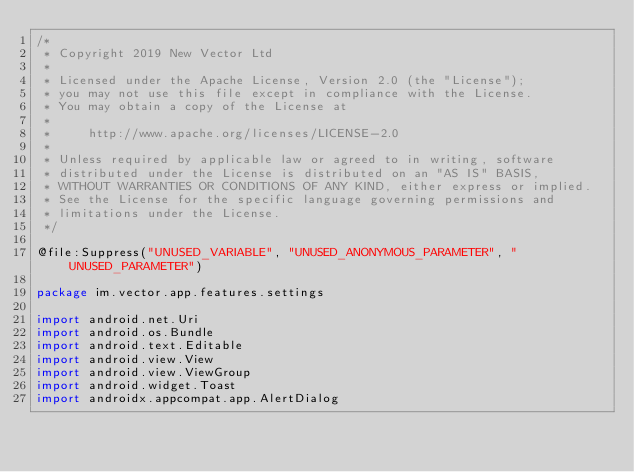<code> <loc_0><loc_0><loc_500><loc_500><_Kotlin_>/*
 * Copyright 2019 New Vector Ltd
 *
 * Licensed under the Apache License, Version 2.0 (the "License");
 * you may not use this file except in compliance with the License.
 * You may obtain a copy of the License at
 *
 *     http://www.apache.org/licenses/LICENSE-2.0
 *
 * Unless required by applicable law or agreed to in writing, software
 * distributed under the License is distributed on an "AS IS" BASIS,
 * WITHOUT WARRANTIES OR CONDITIONS OF ANY KIND, either express or implied.
 * See the License for the specific language governing permissions and
 * limitations under the License.
 */

@file:Suppress("UNUSED_VARIABLE", "UNUSED_ANONYMOUS_PARAMETER", "UNUSED_PARAMETER")

package im.vector.app.features.settings

import android.net.Uri
import android.os.Bundle
import android.text.Editable
import android.view.View
import android.view.ViewGroup
import android.widget.Toast
import androidx.appcompat.app.AlertDialog</code> 